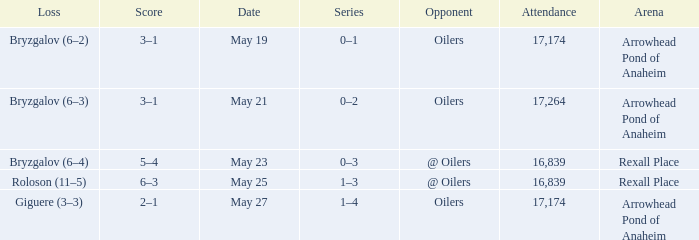Which Attendance has an Opponent of @ oilers, and a Date of may 25? 16839.0. 